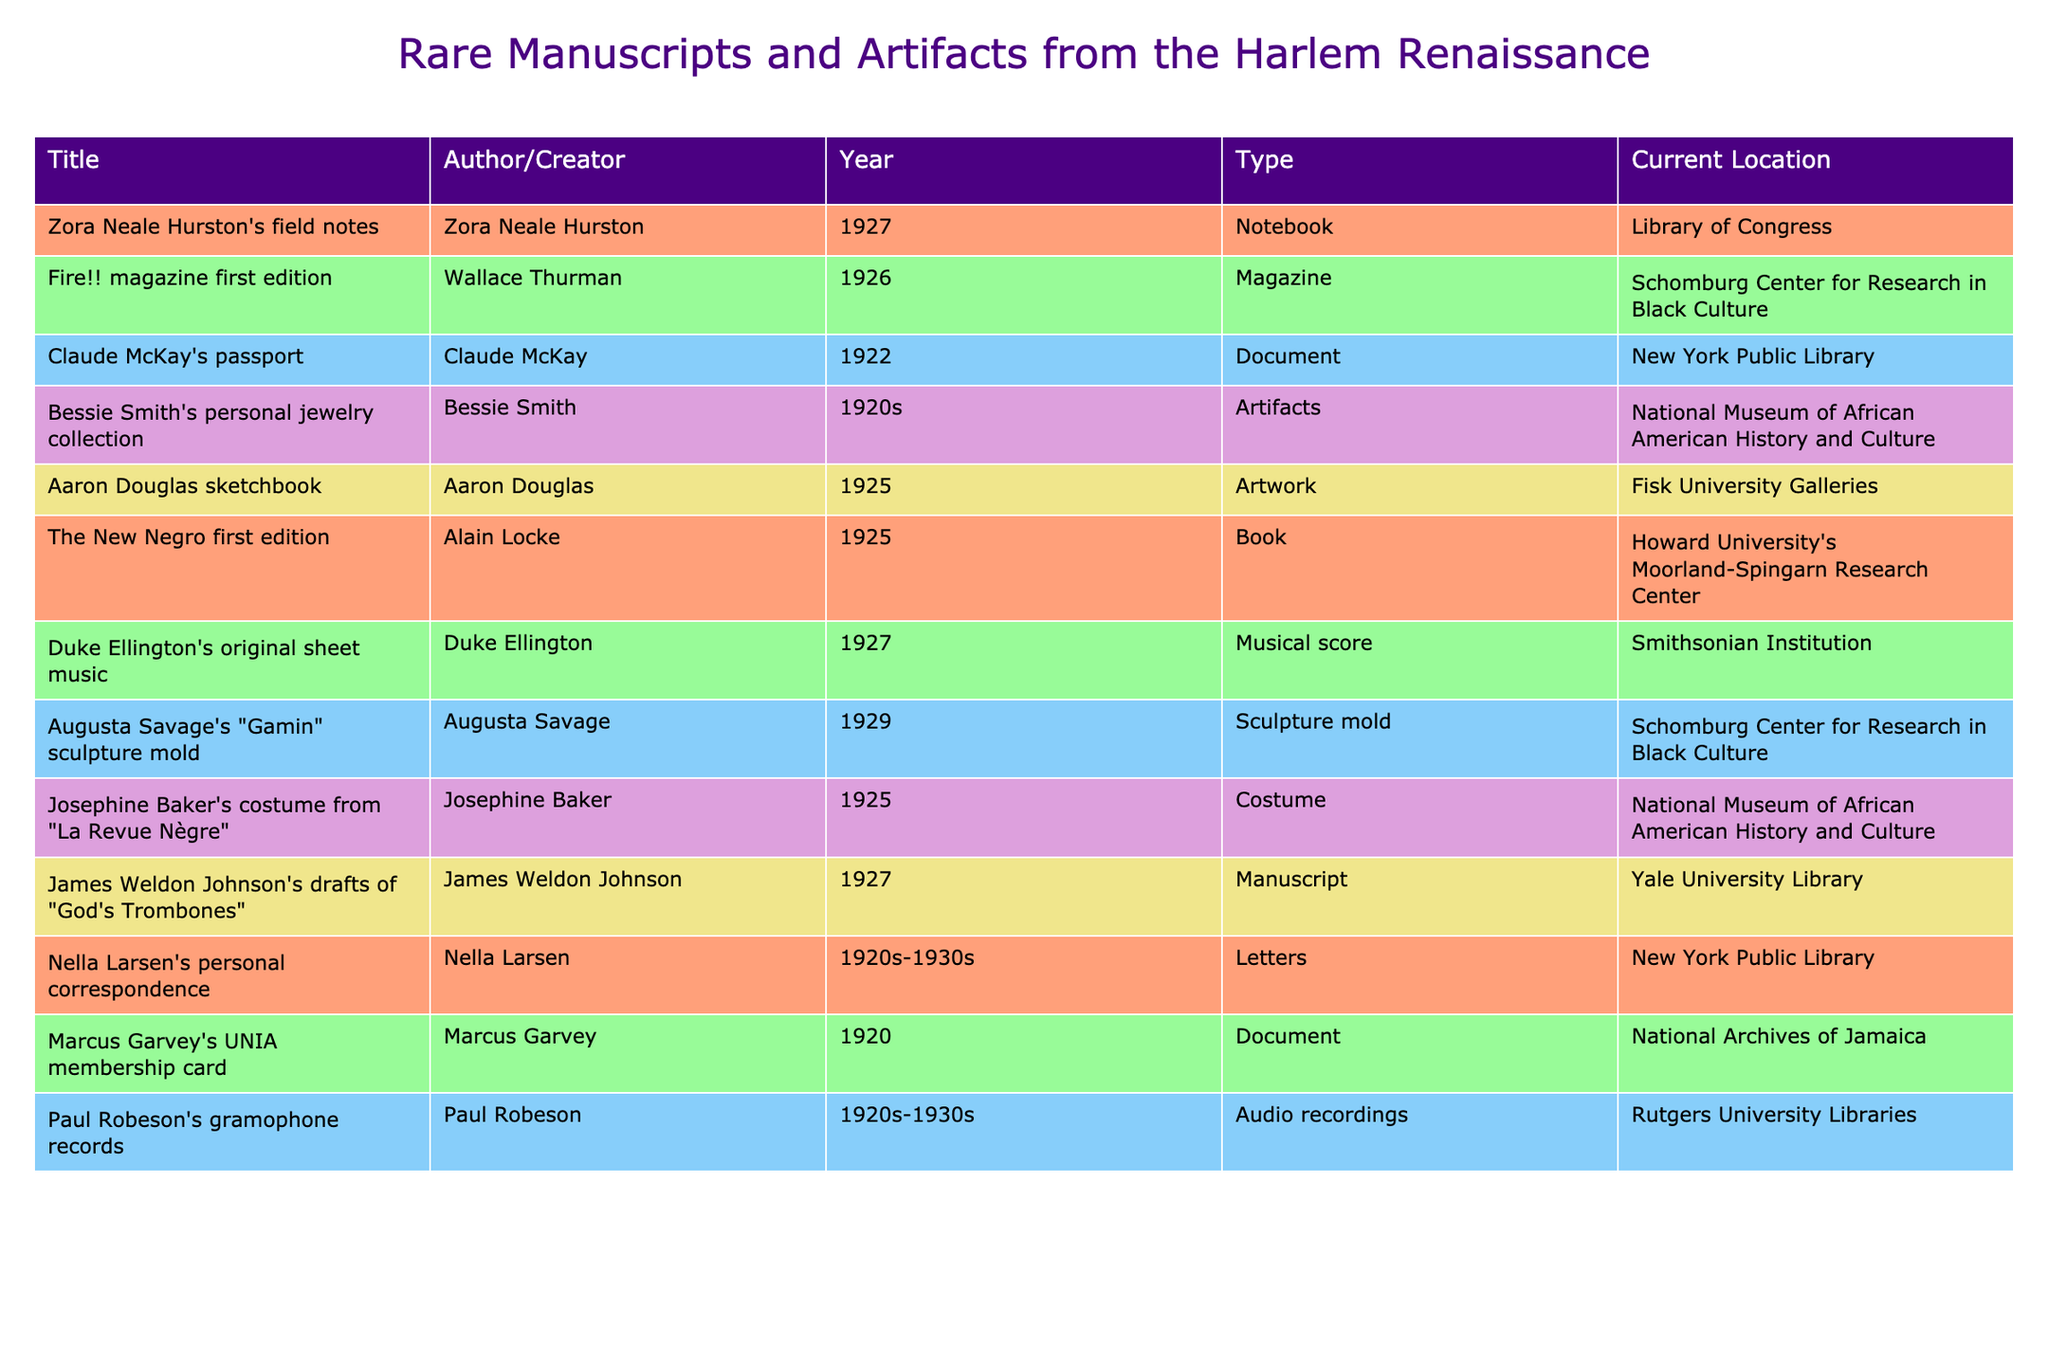What is the title of the document created by Claude McKay? The title of the document is found by looking under the 'Title' column for the row where the 'Author/Creator' is Claude McKay. This shows that the title is "Claude McKay's passport".
Answer: Claude McKay's passport Where is Zora Neale Hurston's field notes currently located? The current location is listed directly in the 'Current Location' column for the row with Zora Neale Hurston's field notes. It indicates that they are at the Library of Congress.
Answer: Library of Congress How many artifacts are listed in the table? By counting the number of entries in the 'Type' column that contain the word "Artifacts", we see that there is one item listed as "Artifacts" (Bessie Smith's personal jewelry collection). Thus, there is only one artifact.
Answer: 1 True or False: Duke Ellington's original sheet music was created in 1925. We look at the 'Year' column for Duke Ellington's original sheet music and see that it was created in 1927, making the statement false.
Answer: False Which author has their personal correspondence from the 1920s to 1930s located at the New York Public Library? We refer to the 'Author/Creator' and 'Current Location' columns, and find that Nella Larsen has personal correspondence listed with the New York Public Library as the current location.
Answer: Nella Larsen What is the difference between the year of publication for "Fire!!" magazine and "The New Negro"? We subtract the year of "The New Negro" (1925) from the year of "Fire!!" magazine (1926). Thus, 1926 - 1925 gives us a difference of 1 year.
Answer: 1 How many documents are listed in the table? To find the number of documents, we look through the 'Type' column for the word "Document" and find two entries (Claude McKay's passport and Marcus Garvey's UNIA membership card).
Answer: 2 Which type of item does Augusta Savage's "Gamin" sculpture mold belong to and where is it located? By checking the 'Type' column for Augusta Savage, we identify that it is a "Sculpture mold" and according to the 'Current Location' column, it is located at the Schomburg Center for Research in Black Culture.
Answer: Sculpture mold, Schomburg Center for Research in Black Culture What is the average publication year of the items listed from the twenty years in the 1920s? We take the years from the items created in the 1920s, which are 1920, 1922, 1925, 1925, 1927, 1927, and find their average: (1920 + 1922 + 1925 + 1925 + 1927 + 1927 + 1925)/7 = 1924.29, rounding it gives us approximately 1924.
Answer: 1924 Which type of artifact did Bessie Smith create and what is its current location? According to the rows, Bessie Smith created a collection of personal jewelry, and the current location is the National Museum of African American History and Culture.
Answer: Personal jewelry collection, National Museum of African American History and Culture 